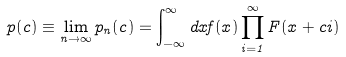Convert formula to latex. <formula><loc_0><loc_0><loc_500><loc_500>p ( c ) \equiv \lim _ { n \to \infty } p _ { n } ( c ) = \int _ { - \infty } ^ { \infty } d x f ( x ) \prod _ { i = 1 } ^ { \infty } F ( x + c i )</formula> 